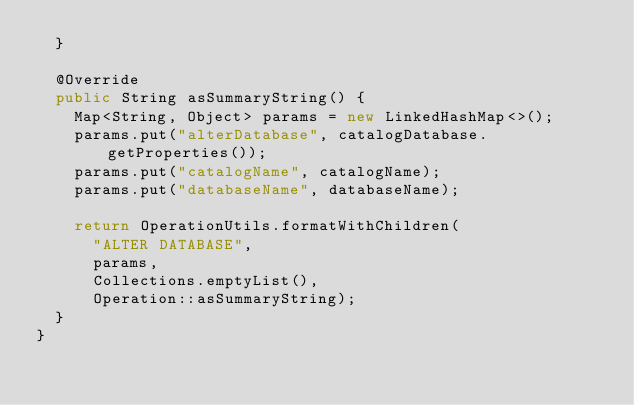<code> <loc_0><loc_0><loc_500><loc_500><_Java_>	}

	@Override
	public String asSummaryString() {
		Map<String, Object> params = new LinkedHashMap<>();
		params.put("alterDatabase", catalogDatabase.getProperties());
		params.put("catalogName", catalogName);
		params.put("databaseName", databaseName);

		return OperationUtils.formatWithChildren(
			"ALTER DATABASE",
			params,
			Collections.emptyList(),
			Operation::asSummaryString);
	}
}
</code> 